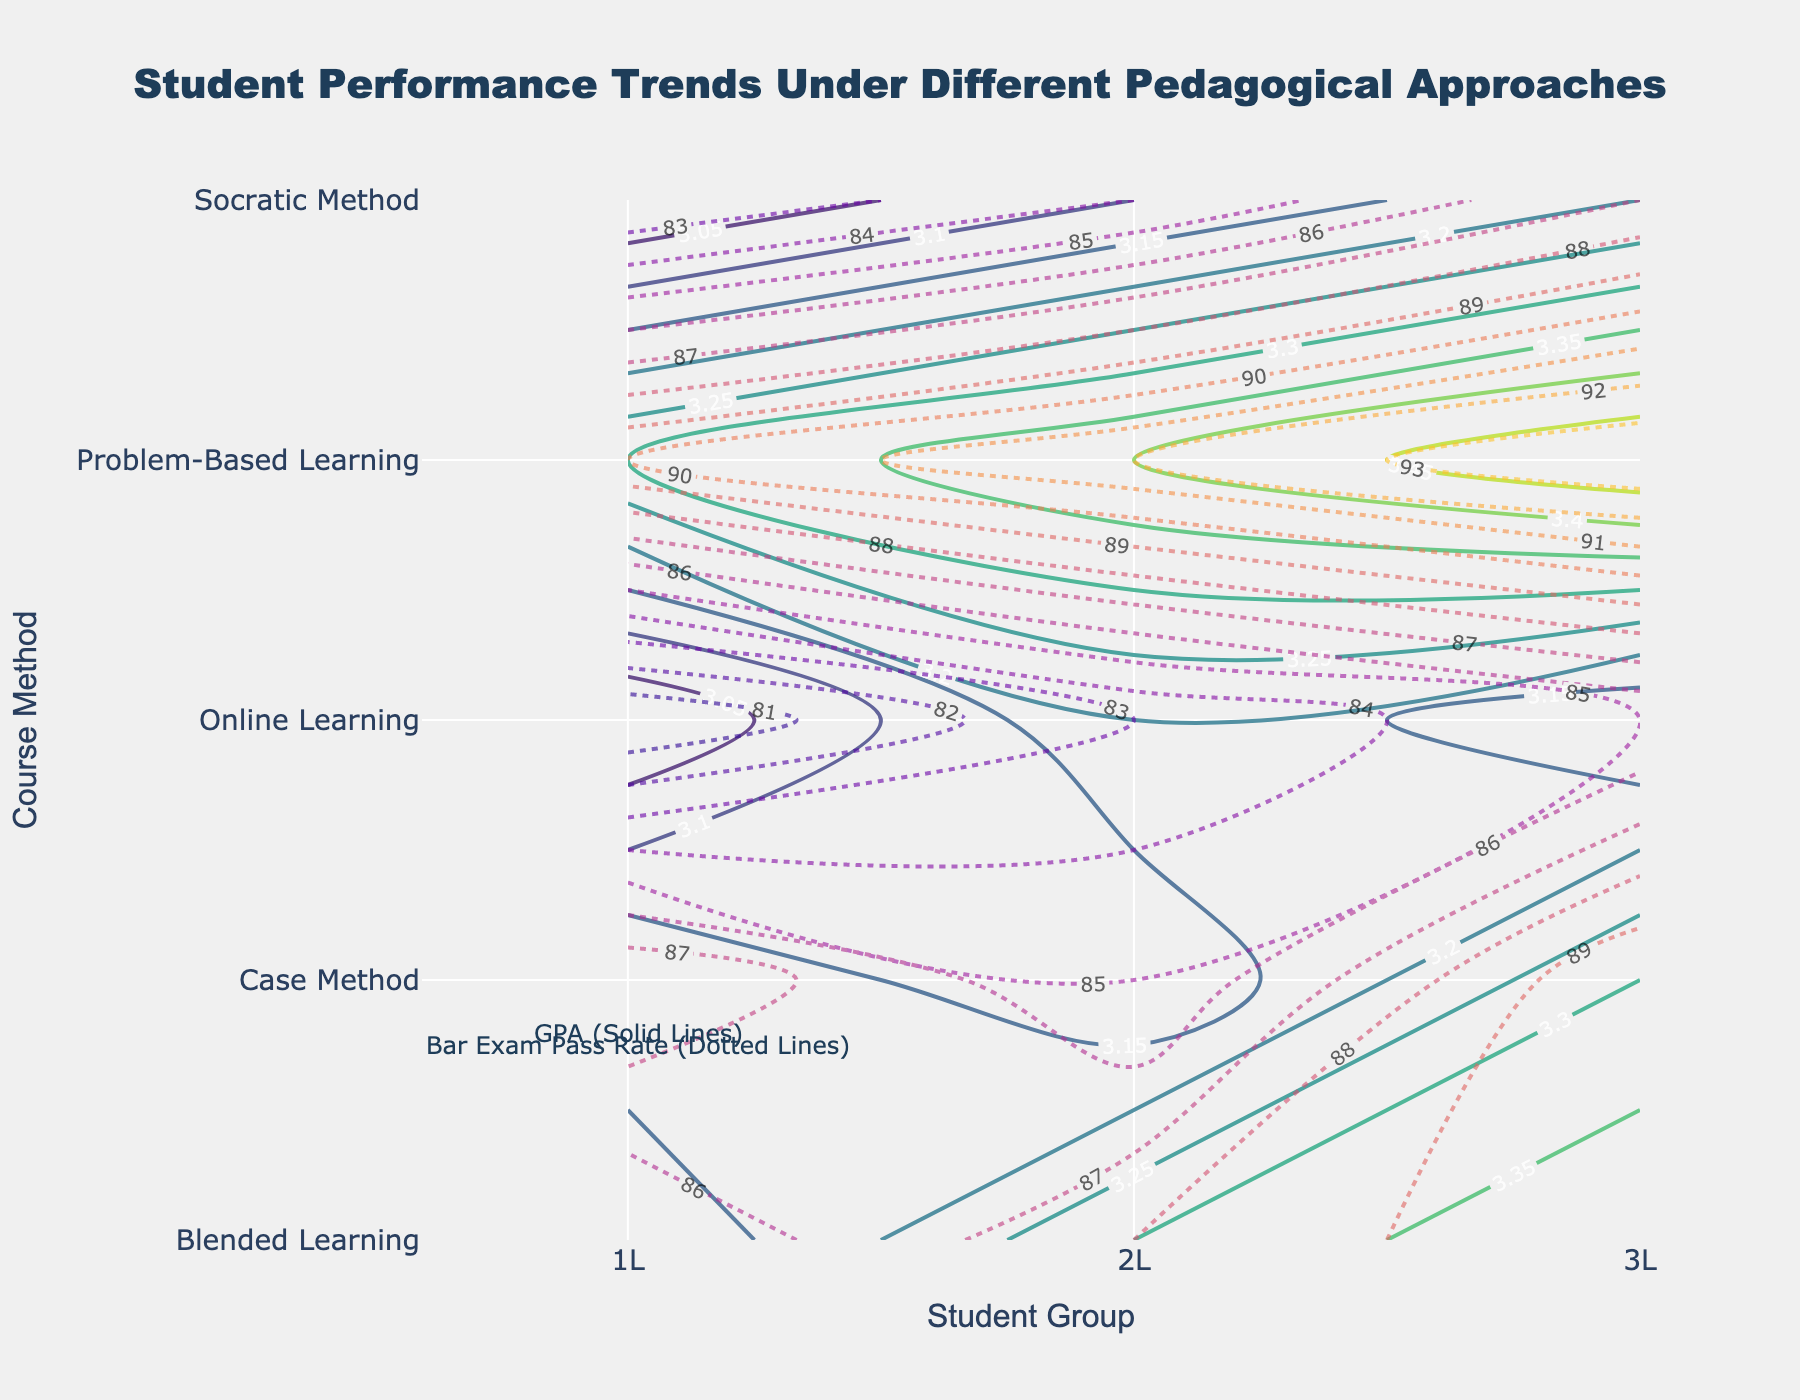What are the two pedagogical approaches compared in the dotted lines for the Bar Exam Pass Rate? The dotted lines represent the Bar Exam Pass Rate contours for different course methods. By examining the legend and the contour lines, we can identify that the dotted contours pertain to the Bar Exam Pass Rate.
Answer: Bar Exam Pass Rate Which course method shows the highest GPA trends? To determine which course method shows the highest GPA trends, look at the solid contour lines indicating GPA. The higher the GPA values, the better the trends.
Answer: Problem-Based Learning How does the GPA of the 2L student group compare across different teaching methods? By examining the contours corresponding to the 2L student group across different teaching methods, we observe the following GPA values: Case Method (3.1), Socratic Method (3.1), Problem-Based Learning (3.4), Blended Learning (3.3), and Online Learning (3.2).
Answer: Problem-Based Learning > Blended Learning > Online Learning > Socratic Method = Case Method What is the general difference in Bar Exam Pass Rates between 1L students using Socratic Method and those using Case Method? The contours show the Bar Exam Pass Rates for Socratic Method (82) and Case Method (88) for 1L students. The difference can be calculated as 88 - 82.
Answer: 6 Which student group generally benefits the most from Online Learning in terms of GPA? Looking at the GPA contours for Online Learning across the student groups, we see values as 1L (3.0), 2L (3.2), and 3L (3.1). The 2L student group shows the highest GPA under Online Learning.
Answer: 2L Are there any student groups with overlapping GPA values between the Case Method and Problem-Based Learning? The solid contours for GPA show that there aren't any overlapping GPA values for different student groups between Case Method and Problem-Based Learning.
Answer: No Which teaching method achieves the highest Bar Exam Pass Rate for 3L students? By looking at the dotted contour lines for the Bar Exam Pass Rate, the highest value for 3L students is obtained under Problem-Based Learning with a rate of 94.
Answer: Problem-Based Learning 